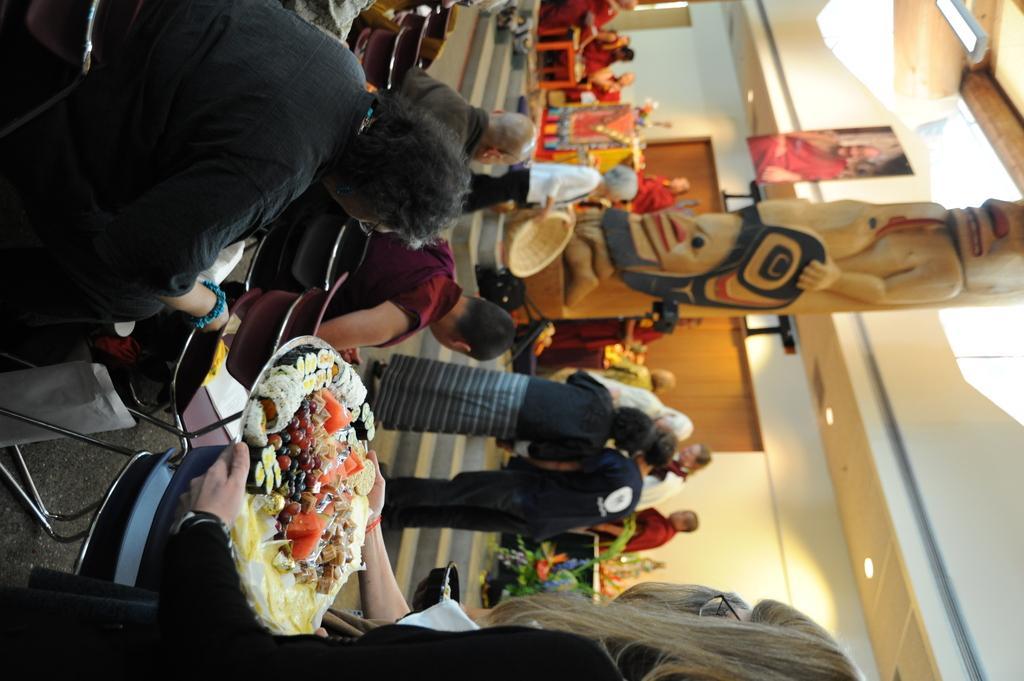In one or two sentences, can you explain what this image depicts? At the bottom there is a lady holding food item on a plate. There are many people sitting on chairs. There are steps. And a person is holding a basket. And there is a statue. On the ceiling there are lights. Also there is a photo frame. There are many people. And there are some decorations. 